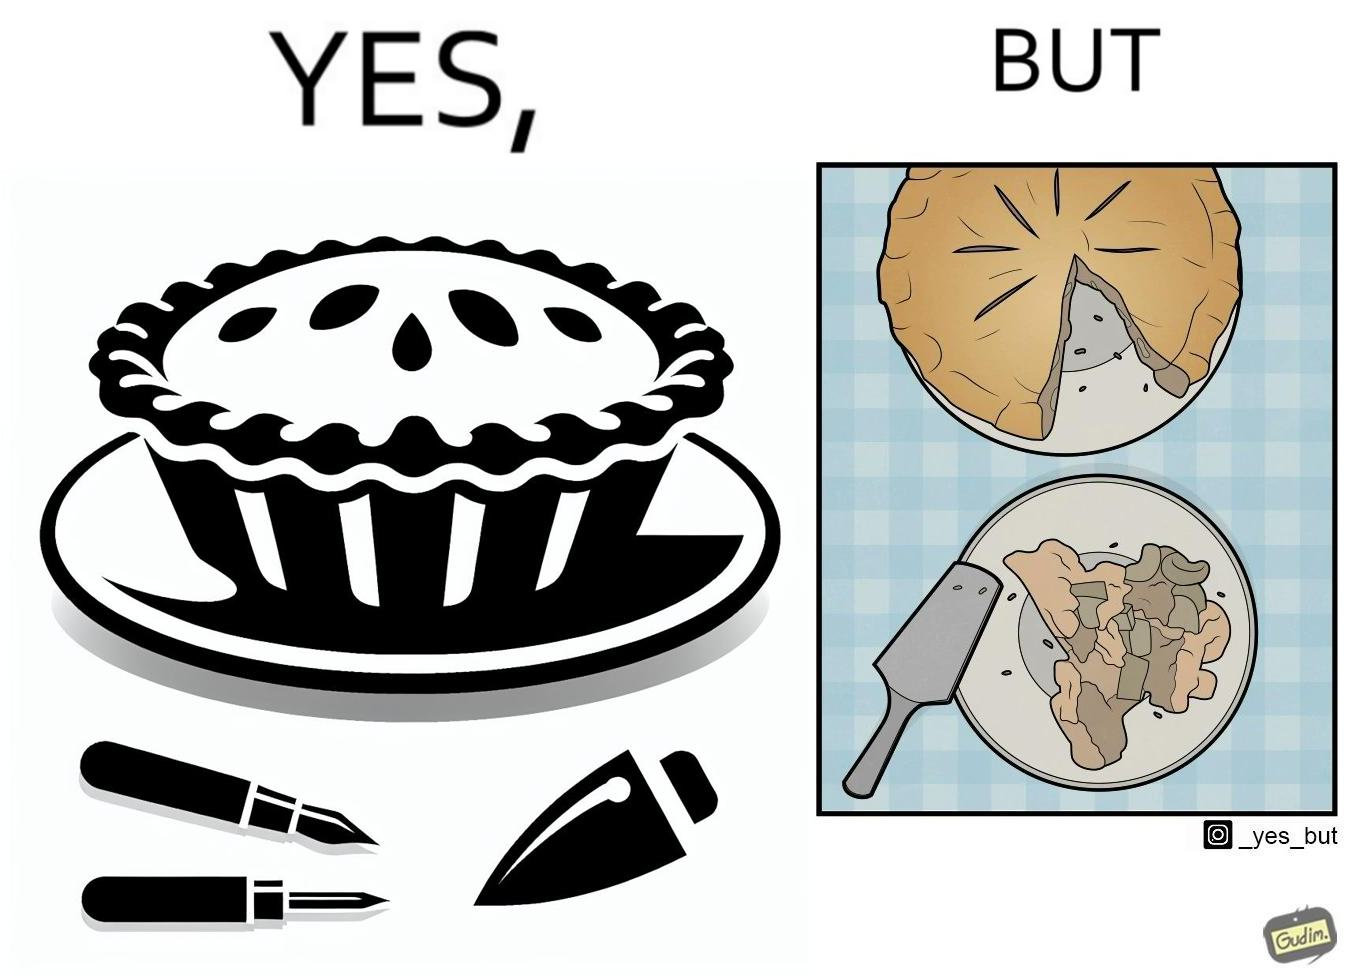Explain the humor or irony in this image. The image is funny because why people like to get whole pies, they only end up eating a small portion of it wasting the rest of the pie. 